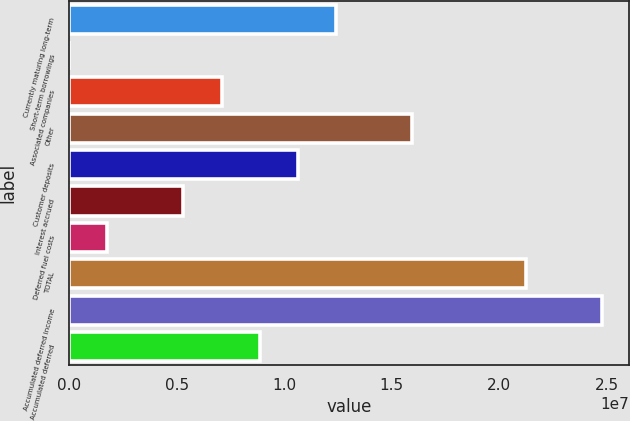Convert chart to OTSL. <chart><loc_0><loc_0><loc_500><loc_500><bar_chart><fcel>Currently maturing long-term<fcel>Short-term borrowings<fcel>Associated companies<fcel>Other<fcel>Customer deposits<fcel>Interest accrued<fcel>Deferred fuel costs<fcel>TOTAL<fcel>Accumulated deferred income<fcel>Accumulated deferred<nl><fcel>1.2392e+07<fcel>3794<fcel>7.08278e+06<fcel>1.59315e+07<fcel>1.06223e+07<fcel>5.31304e+06<fcel>1.77354e+06<fcel>2.12408e+07<fcel>2.47803e+07<fcel>8.85253e+06<nl></chart> 